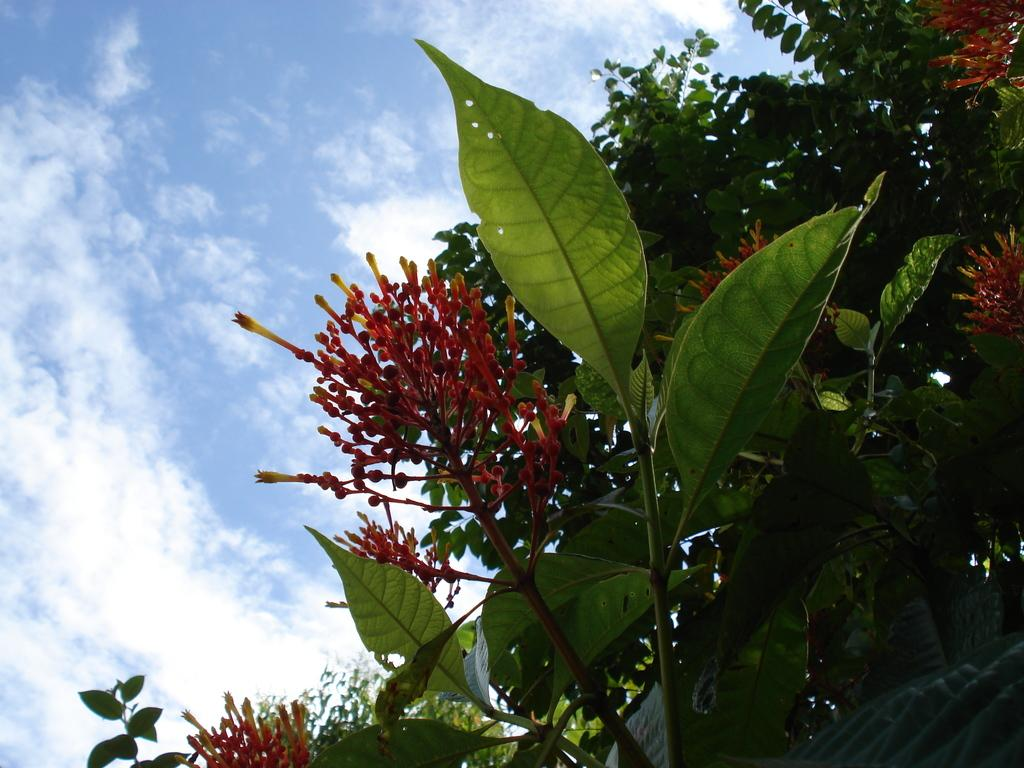What colors are the flowers in the image? The flowers in the image are red and yellow in color. What color are the leaves in the image? The leaves in the image are green in color. What colors can be seen in the sky in the image? The sky in the image is blue and white in color. What type of yoke is being used to write on the leaves in the image? There is no yoke or writing present in the image; it features flowers and leaves with no additional elements. 